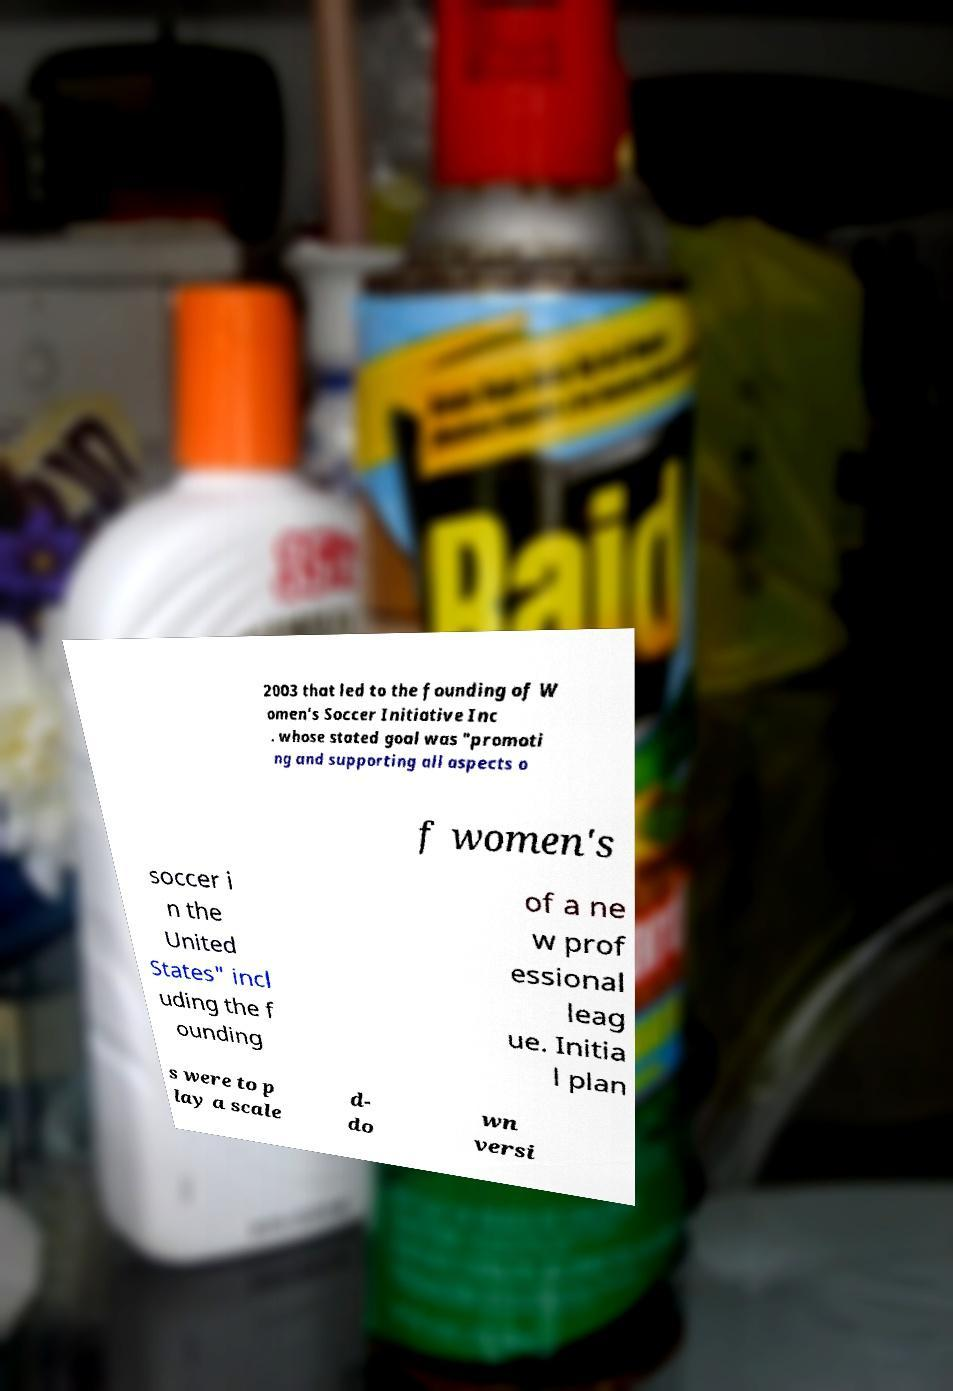Could you assist in decoding the text presented in this image and type it out clearly? 2003 that led to the founding of W omen's Soccer Initiative Inc . whose stated goal was "promoti ng and supporting all aspects o f women's soccer i n the United States" incl uding the f ounding of a ne w prof essional leag ue. Initia l plan s were to p lay a scale d- do wn versi 